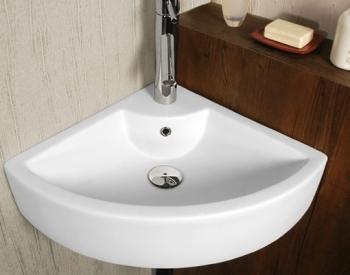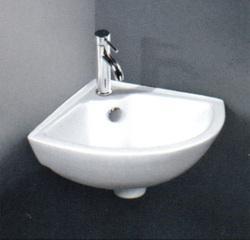The first image is the image on the left, the second image is the image on the right. Examine the images to the left and right. Is the description "At least one sink has no background, just plain white." accurate? Answer yes or no. No. 